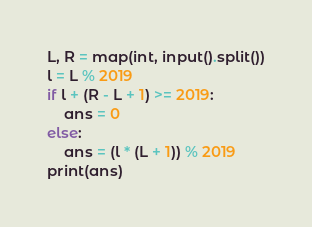Convert code to text. <code><loc_0><loc_0><loc_500><loc_500><_Python_>L, R = map(int, input().split())
l = L % 2019
if l + (R - L + 1) >= 2019:
    ans = 0
else:
    ans = (l * (L + 1)) % 2019
print(ans)</code> 